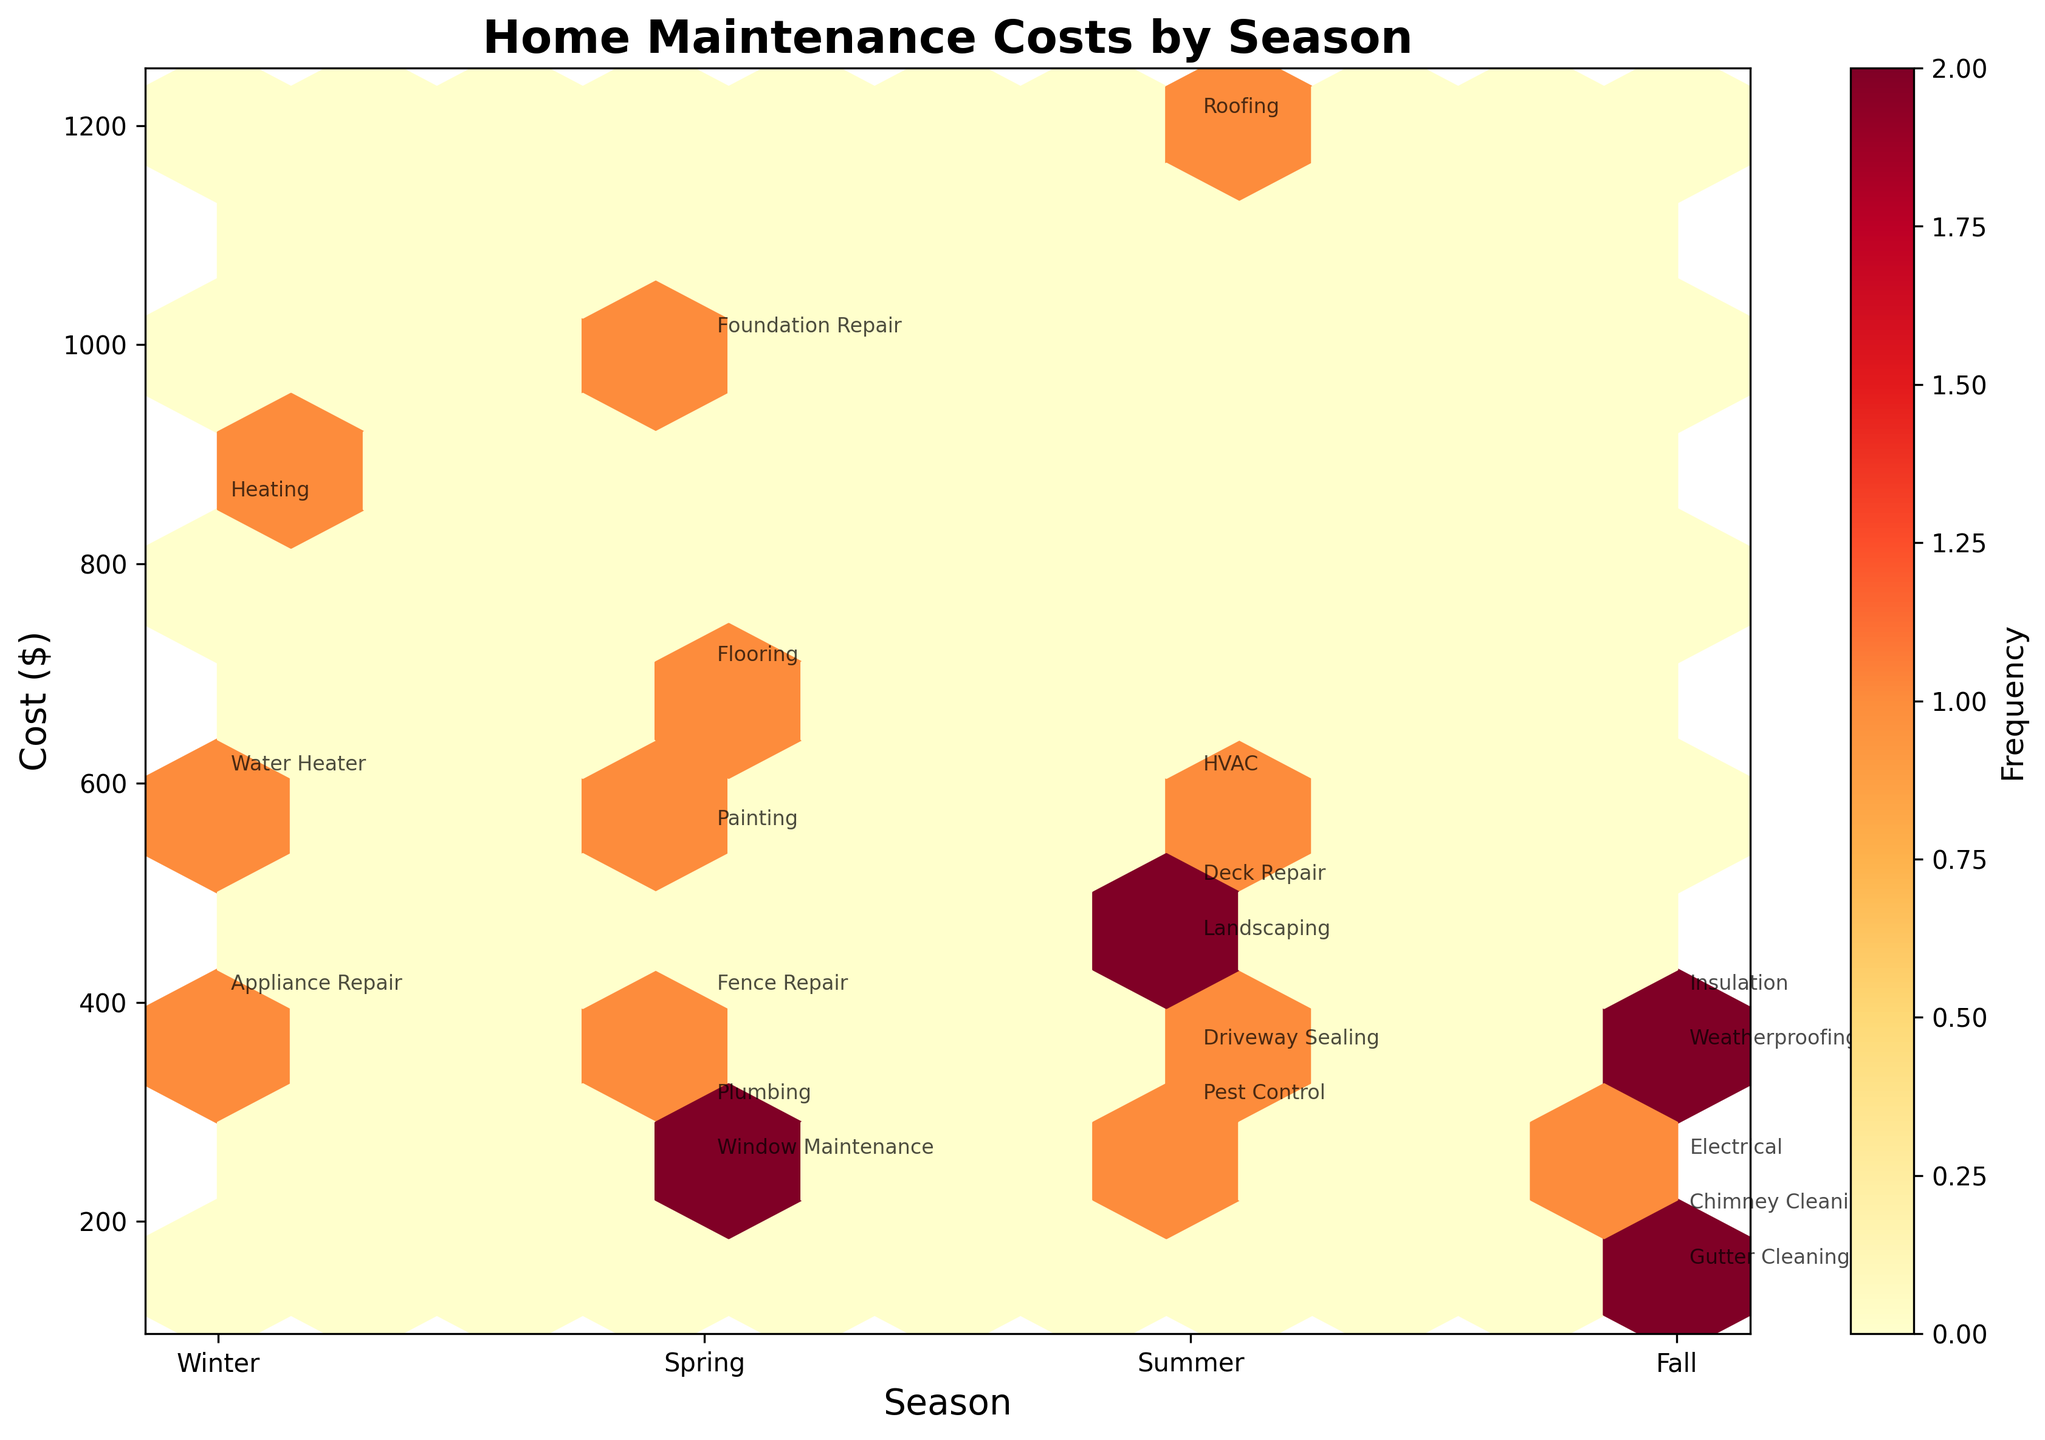What is the title of the plot? The title of the plot is generally placed at the top and usually stands out. In this case, it reads "Home Maintenance Costs by Season."
Answer: Home Maintenance Costs by Season Which season has the highest number of home maintenance activities according to the plot? To determine this, look at which season has the most data points (hexagons) annotated with specific home maintenance activities. Summer appears to have the highest number of activities.
Answer: Summer What is the distribution of costs for Spring, and which specific maintenance activity has the highest cost in Spring? For Spring, observe the range of maintenance costs along the y-axis labeled "Spring." Among these points, Foundation Repair has the highest cost at $1000.
Answer: Foundation Repair How do the costs of Winter home maintenance activities compare to those in Fall? To compare, note the areas covered by the data points along the y-axis for Winter and Fall. Winter has higher individual costs (e.g., Heating at $850) compared to Fall, which has relatively lower costs (e.g., Gutter Cleaning at $150).
Answer: Winter generally has higher individual costs How frequently are high-cost home maintenance activities observed in Summer? The color intensity of the hexagons in Summer (lighter to darker shades) indicates frequency. More high-cost activities (e.g., Roofing at $1200) are visible, suggesting higher costs are more frequent.
Answer: Frequent Which season has the least varied maintenance costs? Look at the spread of data points within each season. Fall has a tight cluster of points, indicating less variance in costs.
Answer: Fall Between Summer and Winter, which season has the highest single maintenance cost, and what is it? Observe the peaks in each season along the y-axis. Summer has the highest single cost with Roofing at $1200.
Answer: Summer, $1200 In which season do most of the low-cost maintenance activities fall? Identify which season has the most data points at the lower end of the cost spectrum. Fall has several low-cost activities (e.g., Gutter Cleaning at $150).
Answer: Fall What is the aggregate of all maintenance costs in Winter? Sum up all the costs in Winter: Heating (850) + Appliance Repair (400) + Water Heater (600) = 1850.
Answer: $1850 What can be inferred about the correlation between seasons and maintenance costs from the plot? The plotted data suggests some correlation: Summer and Winter tend to have higher individual maintenance costs compared to Spring and Fall, as evidenced by the distribution of annotated points.
Answer: Higher costs in Summer and Winter 